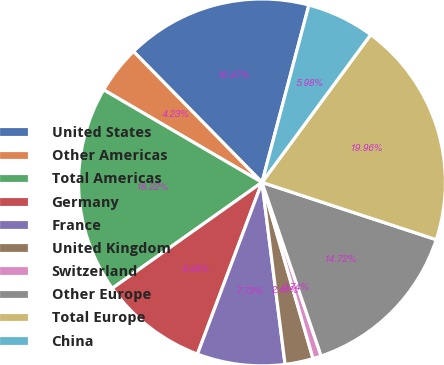<chart> <loc_0><loc_0><loc_500><loc_500><pie_chart><fcel>United States<fcel>Other Americas<fcel>Total Americas<fcel>Germany<fcel>France<fcel>United Kingdom<fcel>Switzerland<fcel>Other Europe<fcel>Total Europe<fcel>China<nl><fcel>16.47%<fcel>4.23%<fcel>18.22%<fcel>9.48%<fcel>7.73%<fcel>2.48%<fcel>0.74%<fcel>14.72%<fcel>19.96%<fcel>5.98%<nl></chart> 